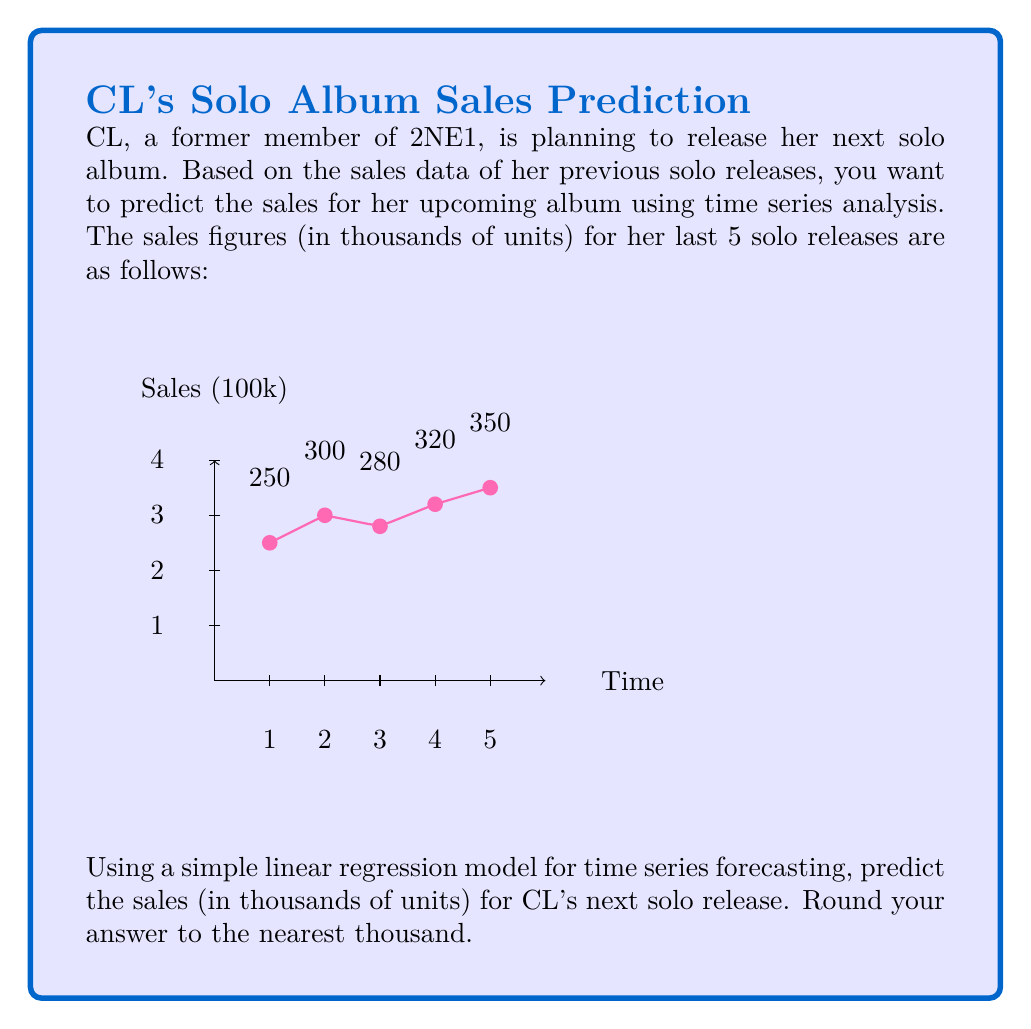Solve this math problem. To predict the sales for CL's next solo release using a simple linear regression model, we'll follow these steps:

1) First, let's set up our data:
   Time (x): 1, 2, 3, 4, 5
   Sales (y): 250, 300, 280, 320, 350 (in thousands)

2) We need to calculate the following:
   n = 5 (number of data points)
   ∑x = 1 + 2 + 3 + 4 + 5 = 15
   ∑y = 250 + 300 + 280 + 320 + 350 = 1500
   ∑(x^2) = 1^2 + 2^2 + 3^2 + 4^2 + 5^2 = 55
   ∑(xy) = 1(250) + 2(300) + 3(280) + 4(320) + 5(350) = 4660

3) Now we can calculate the slope (m) and y-intercept (b) of our regression line:

   $$m = \frac{n\sum(xy) - \sum x \sum y}{n\sum(x^2) - (\sum x)^2}$$
   
   $$m = \frac{5(4660) - 15(1500)}{5(55) - 15^2} = \frac{23300 - 22500}{275 - 225} = \frac{800}{50} = 16$$

   $$b = \frac{\sum y - m\sum x}{n}$$
   
   $$b = \frac{1500 - 16(15)}{5} = \frac{1500 - 240}{5} = 252$$

4) Our regression line equation is:
   y = 16x + 252

5) To predict the sales for the next release (x = 6):
   y = 16(6) + 252 = 96 + 252 = 348

Therefore, the predicted sales for CL's next solo release would be 348 thousand units. Rounding to the nearest thousand, we get 348,000 units.
Answer: 348,000 units 